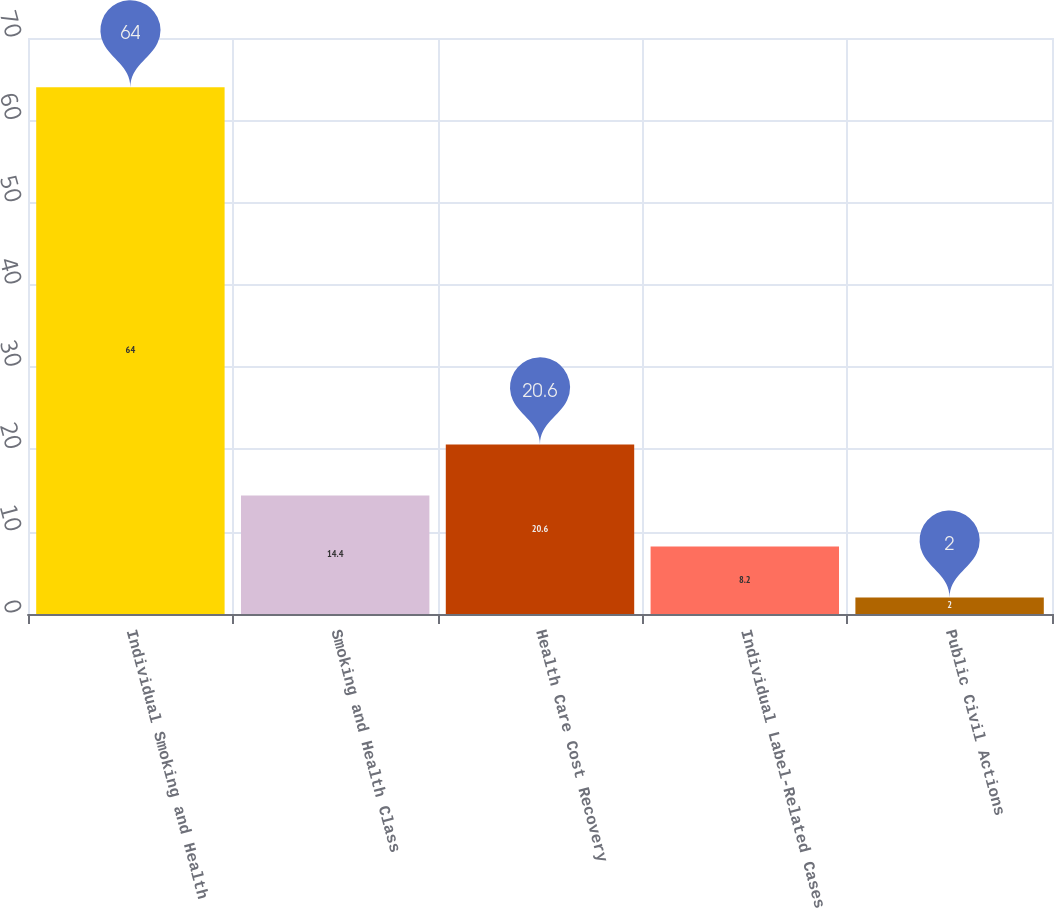Convert chart. <chart><loc_0><loc_0><loc_500><loc_500><bar_chart><fcel>Individual Smoking and Health<fcel>Smoking and Health Class<fcel>Health Care Cost Recovery<fcel>Individual Label-Related Cases<fcel>Public Civil Actions<nl><fcel>64<fcel>14.4<fcel>20.6<fcel>8.2<fcel>2<nl></chart> 